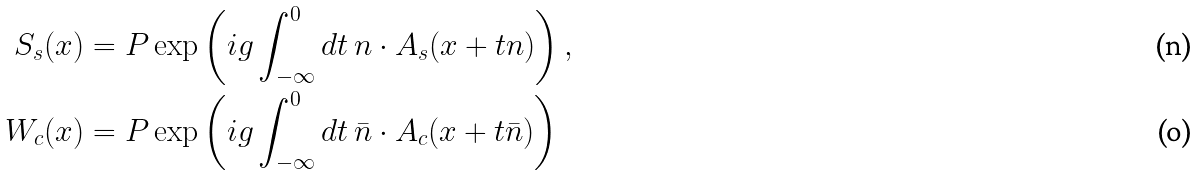Convert formula to latex. <formula><loc_0><loc_0><loc_500><loc_500>S _ { s } ( x ) & = P \exp \left ( i g \int _ { - \infty } ^ { 0 } d t \, n \cdot A _ { s } ( x + t n ) \right ) , \\ W _ { c } ( x ) & = P \exp \left ( i g \int _ { - \infty } ^ { 0 } d t \, \bar { n } \cdot A _ { c } ( x + t \bar { n } ) \right )</formula> 